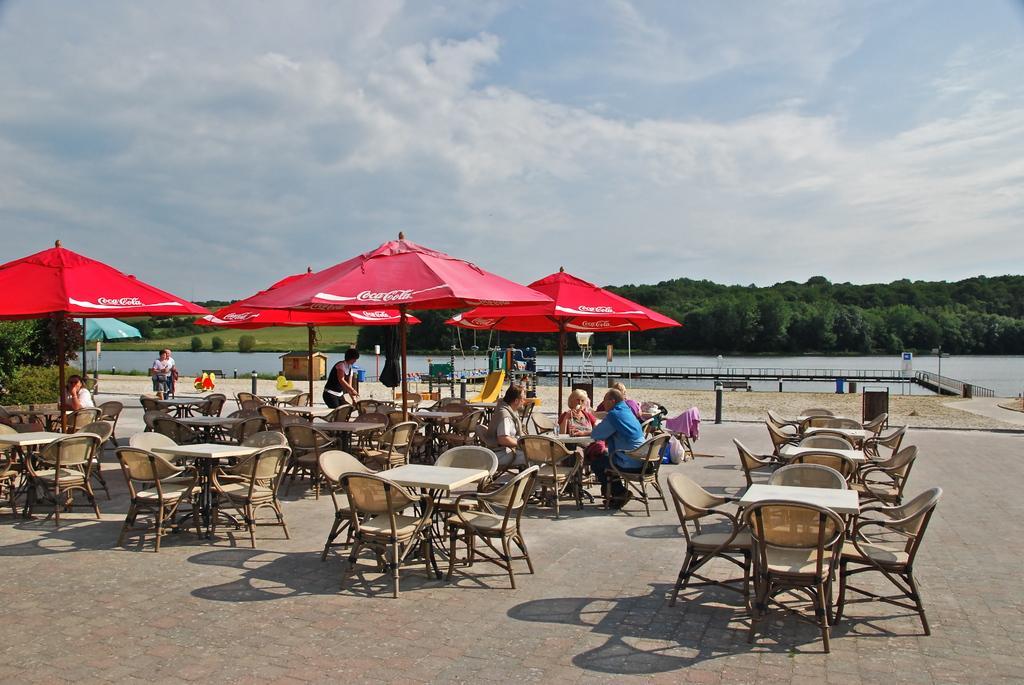In one or two sentences, can you explain what this image depicts? In this picture there are many people with coca cola tent on top of them. In the background there is beautiful scenery and a lake. 